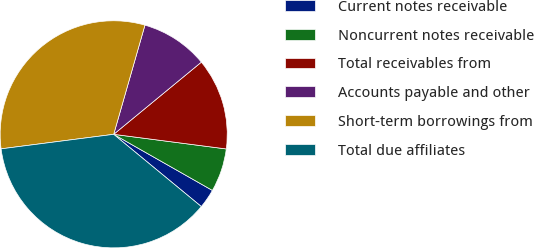Convert chart to OTSL. <chart><loc_0><loc_0><loc_500><loc_500><pie_chart><fcel>Current notes receivable<fcel>Noncurrent notes receivable<fcel>Total receivables from<fcel>Accounts payable and other<fcel>Short-term borrowings from<fcel>Total due affiliates<nl><fcel>2.75%<fcel>6.17%<fcel>13.02%<fcel>9.6%<fcel>31.48%<fcel>36.98%<nl></chart> 